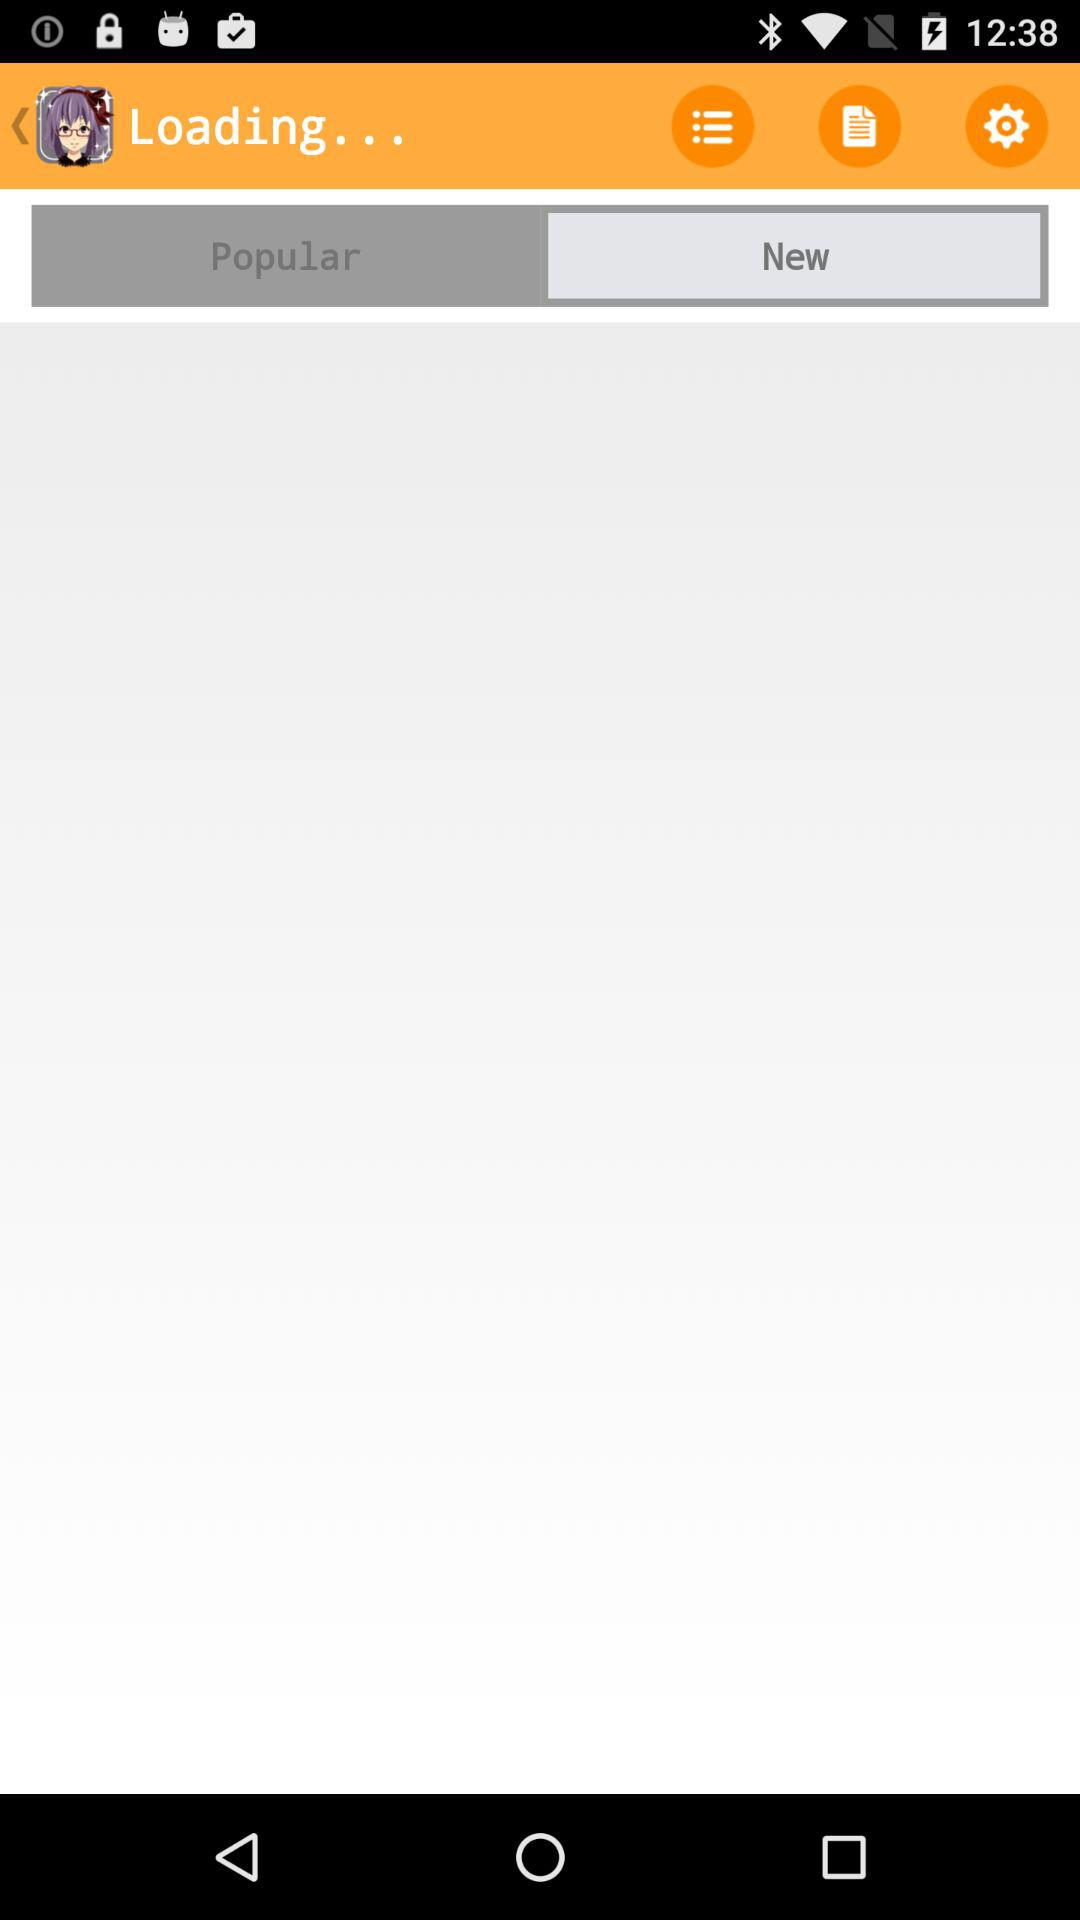Which tab is selected? The selected tab is "New". 